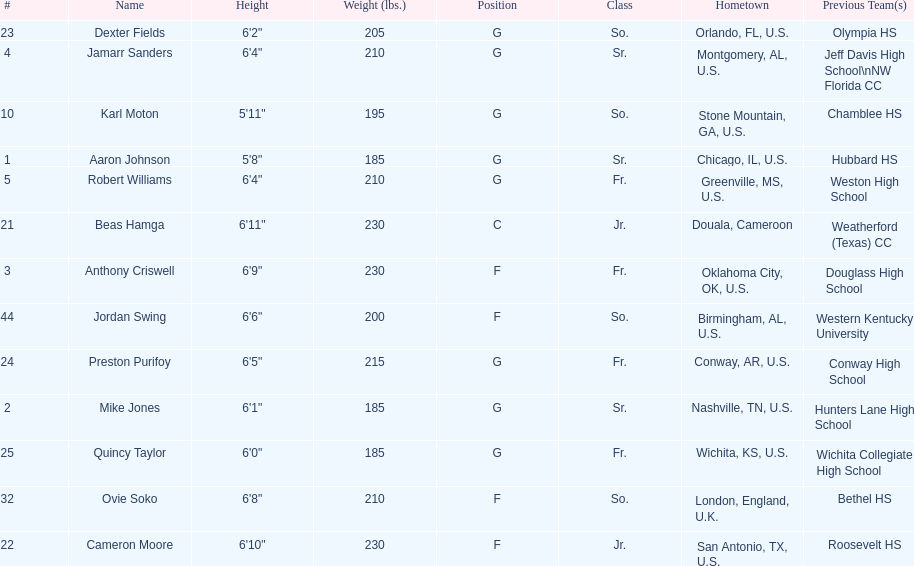Would you be able to parse every entry in this table? {'header': ['#', 'Name', 'Height', 'Weight (lbs.)', 'Position', 'Class', 'Hometown', 'Previous Team(s)'], 'rows': [['23', 'Dexter Fields', '6\'2"', '205', 'G', 'So.', 'Orlando, FL, U.S.', 'Olympia HS'], ['4', 'Jamarr Sanders', '6\'4"', '210', 'G', 'Sr.', 'Montgomery, AL, U.S.', 'Jeff Davis High School\\nNW Florida CC'], ['10', 'Karl Moton', '5\'11"', '195', 'G', 'So.', 'Stone Mountain, GA, U.S.', 'Chamblee HS'], ['1', 'Aaron Johnson', '5\'8"', '185', 'G', 'Sr.', 'Chicago, IL, U.S.', 'Hubbard HS'], ['5', 'Robert Williams', '6\'4"', '210', 'G', 'Fr.', 'Greenville, MS, U.S.', 'Weston High School'], ['21', 'Beas Hamga', '6\'11"', '230', 'C', 'Jr.', 'Douala, Cameroon', 'Weatherford (Texas) CC'], ['3', 'Anthony Criswell', '6\'9"', '230', 'F', 'Fr.', 'Oklahoma City, OK, U.S.', 'Douglass High School'], ['44', 'Jordan Swing', '6\'6"', '200', 'F', 'So.', 'Birmingham, AL, U.S.', 'Western Kentucky University'], ['24', 'Preston Purifoy', '6\'5"', '215', 'G', 'Fr.', 'Conway, AR, U.S.', 'Conway High School'], ['2', 'Mike Jones', '6\'1"', '185', 'G', 'Sr.', 'Nashville, TN, U.S.', 'Hunters Lane High School'], ['25', 'Quincy Taylor', '6\'0"', '185', 'G', 'Fr.', 'Wichita, KS, U.S.', 'Wichita Collegiate High School'], ['32', 'Ovie Soko', '6\'8"', '210', 'F', 'So.', 'London, England, U.K.', 'Bethel HS'], ['22', 'Cameron Moore', '6\'10"', '230', 'F', 'Jr.', 'San Antonio, TX, U.S.', 'Roosevelt HS']]} How many players were on the 2010-11 uab blazers men's basketball team? 13. 